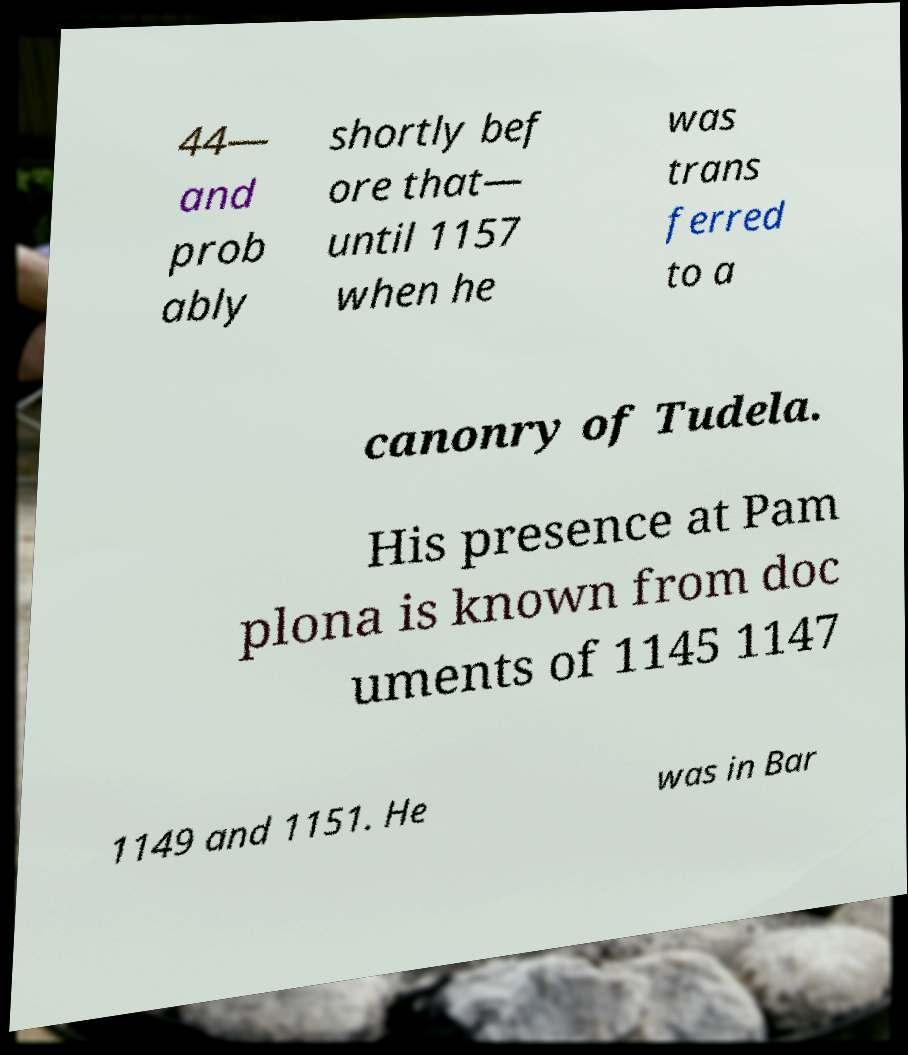Please read and relay the text visible in this image. What does it say? 44— and prob ably shortly bef ore that— until 1157 when he was trans ferred to a canonry of Tudela. His presence at Pam plona is known from doc uments of 1145 1147 1149 and 1151. He was in Bar 